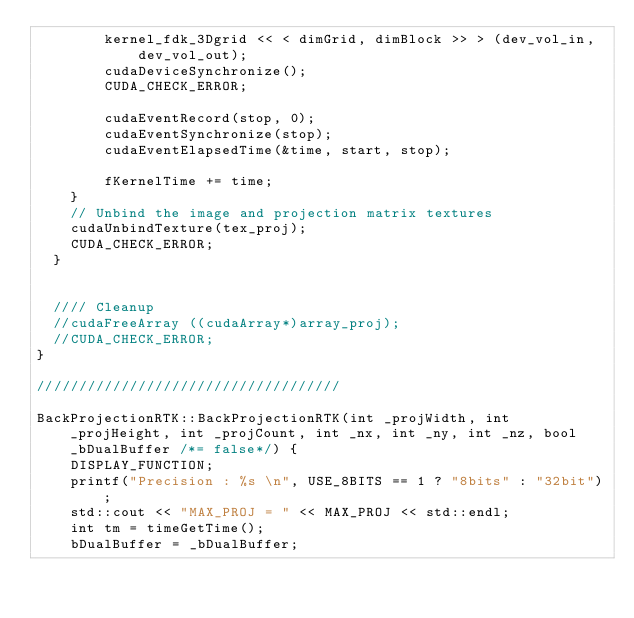Convert code to text. <code><loc_0><loc_0><loc_500><loc_500><_Cuda_>		kernel_fdk_3Dgrid << < dimGrid, dimBlock >> > (dev_vol_in,
			dev_vol_out);
		cudaDeviceSynchronize();
		CUDA_CHECK_ERROR;

		cudaEventRecord(stop, 0);
		cudaEventSynchronize(stop);
		cudaEventElapsedTime(&time, start, stop);

		fKernelTime += time;
	}
	// Unbind the image and projection matrix textures
	cudaUnbindTexture(tex_proj);
	CUDA_CHECK_ERROR;
  }


  //// Cleanup
  //cudaFreeArray ((cudaArray*)array_proj);
  //CUDA_CHECK_ERROR;
}

////////////////////////////////////

BackProjectionRTK::BackProjectionRTK(int _projWidth, int _projHeight, int _projCount, int _nx, int _ny, int _nz, bool _bDualBuffer /*= false*/) {
	DISPLAY_FUNCTION;
	printf("Precision : %s \n", USE_8BITS == 1 ? "8bits" : "32bit");
	std::cout << "MAX_PROJ = " << MAX_PROJ << std::endl;
	int tm = timeGetTime();
	bDualBuffer = _bDualBuffer;</code> 